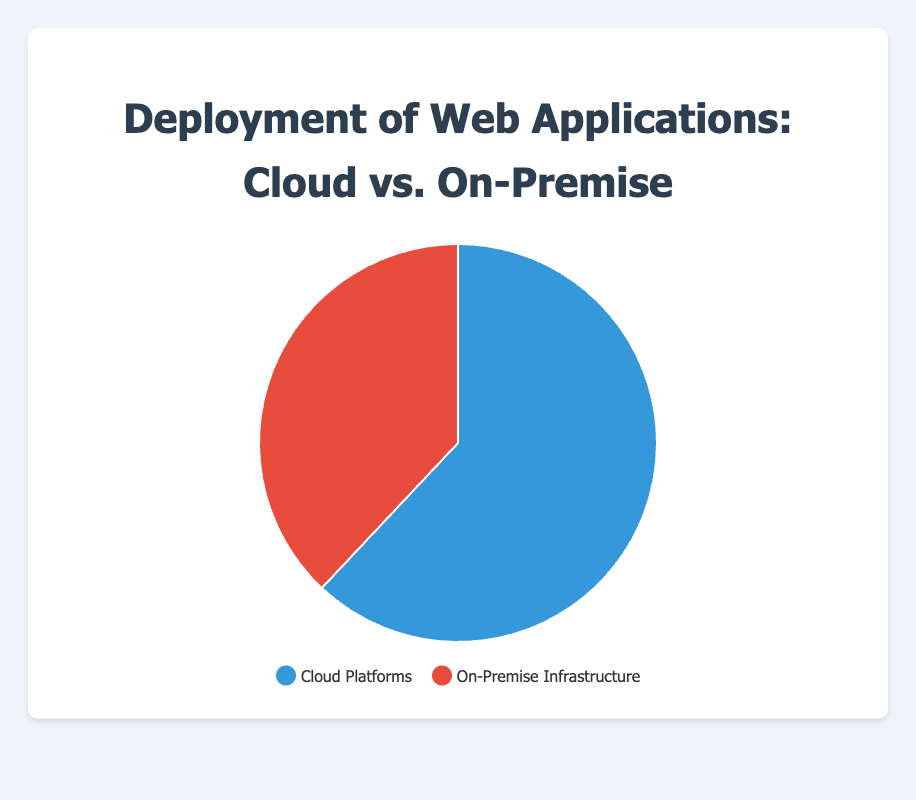Which deployment method is more prevalent? The chart shows that Cloud Platforms have a higher percentage (62%) compared to On-Premise Infrastructure (38%).
Answer: Cloud Platforms What is the percentage difference between Cloud Platforms and On-Premise Infrastructure? Subtract the percentage of On-Premise Infrastructure (38%) from Cloud Platforms (62%), which gives 62 - 38.
Answer: 24% Which category has a larger share in the pie chart, Cloud Platforms or On-Premise Infrastructure? Comparing 62% (Cloud Platforms) and 38% (On-Premise Infrastructure), it's clear that Cloud Platforms have a larger share.
Answer: Cloud Platforms What proportion of deployments are done on On-Premise Infrastructure? The pie chart shows that On-Premise Infrastructure makes up 38% of the deployments.
Answer: 38% If the total number of deployments is 100, how many are on Cloud Platforms? Given that Cloud Platforms account for 62%, multiply 100 by 0.62 to find the number of deployments.
Answer: 62 What does the blue section of the pie chart represent? The legend indicates that the blue color represents deployments on Cloud Platforms.
Answer: Cloud Platforms What can you infer about the trend in the choice between Cloud Platforms and On-Premise Infrastructure? Since Cloud Platforms have a higher percentage (62%) compared to On-Premise Infrastructure (38%), we can infer that more organizations prefer deploying on Cloud Platforms.
Answer: More organizations prefer Cloud Platforms How much smaller in proportion is On-Premise Infrastructure compared to Cloud Platforms? Calculate the ratio of the differences: (62 - 38) / 62. Divide the difference (24%) by the larger segment (62%).
Answer: Approximately 38.7% Which segment uses a red color in the pie chart? The legend states that the red color represents On-Premise Infrastructure.
Answer: On-Premise Infrastructure 